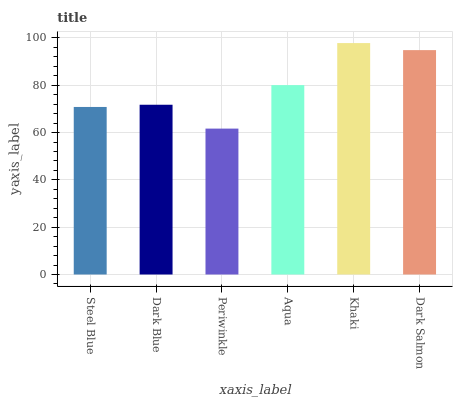Is Dark Blue the minimum?
Answer yes or no. No. Is Dark Blue the maximum?
Answer yes or no. No. Is Dark Blue greater than Steel Blue?
Answer yes or no. Yes. Is Steel Blue less than Dark Blue?
Answer yes or no. Yes. Is Steel Blue greater than Dark Blue?
Answer yes or no. No. Is Dark Blue less than Steel Blue?
Answer yes or no. No. Is Aqua the high median?
Answer yes or no. Yes. Is Dark Blue the low median?
Answer yes or no. Yes. Is Steel Blue the high median?
Answer yes or no. No. Is Dark Salmon the low median?
Answer yes or no. No. 